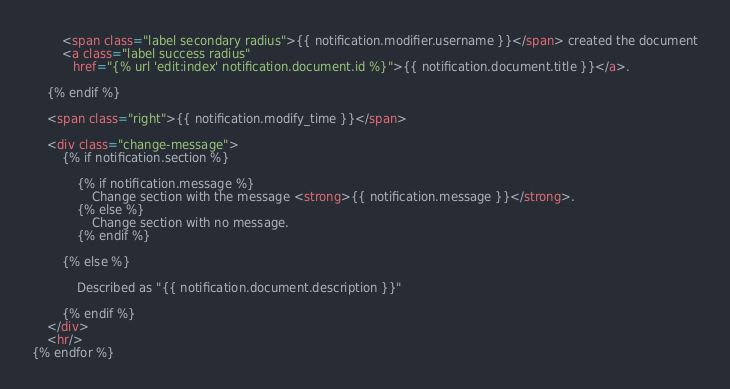<code> <loc_0><loc_0><loc_500><loc_500><_HTML_>
        <span class="label secondary radius">{{ notification.modifier.username }}</span> created the document
        <a class="label success radius"
           href="{% url 'edit:index' notification.document.id %}">{{ notification.document.title }}</a>.

    {% endif %}

    <span class="right">{{ notification.modify_time }}</span>

    <div class="change-message">
        {% if notification.section %}

            {% if notification.message %}
                Change section with the message <strong>{{ notification.message }}</strong>.
            {% else %}
                Change section with no message.
            {% endif %}

        {% else %}

            Described as "{{ notification.document.description }}"

        {% endif %}
    </div>
    <hr/>
{% endfor %}</code> 